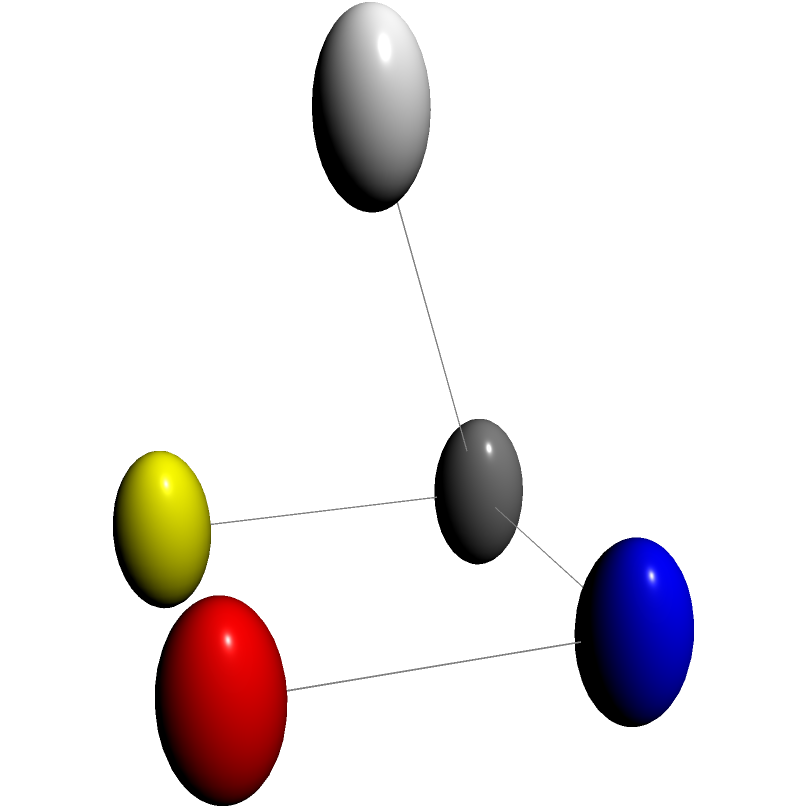Based on the 3D representation of a protein molecule fragment shown above, which amino acid is most likely represented, and what type of bond is formed between the central carbon atom and the nitrogen atom? To answer this question, we need to analyze the structure step-by-step:

1. Identify the central atom: The central atom is carbon (C), which is typical for amino acids.

2. Analyze the attached atoms:
   - Nitrogen (N) is attached to the central carbon, indicating an amino group.
   - Oxygen (O) is attached to the nitrogen, suggesting a peptide bond.
   - Sulfur (S) is attached to the central carbon, which is characteristic of only one amino acid.
   - Hydrogen (H) is also attached to the central carbon.

3. Identify the amino acid:
   The presence of sulfur directly attached to the central carbon is unique to the amino acid cysteine.

4. Determine the bond type between C and N:
   The bond between the central carbon and the nitrogen is a single covalent bond, typically referred to as a peptide bond in protein structures.

5. Consider the context:
   In a protein structure, this representation would be part of a larger peptide chain, with the nitrogen participating in a peptide bond with the previous amino acid and the oxygen participating in a peptide bond with the next amino acid.
Answer: Cysteine; peptide bond 